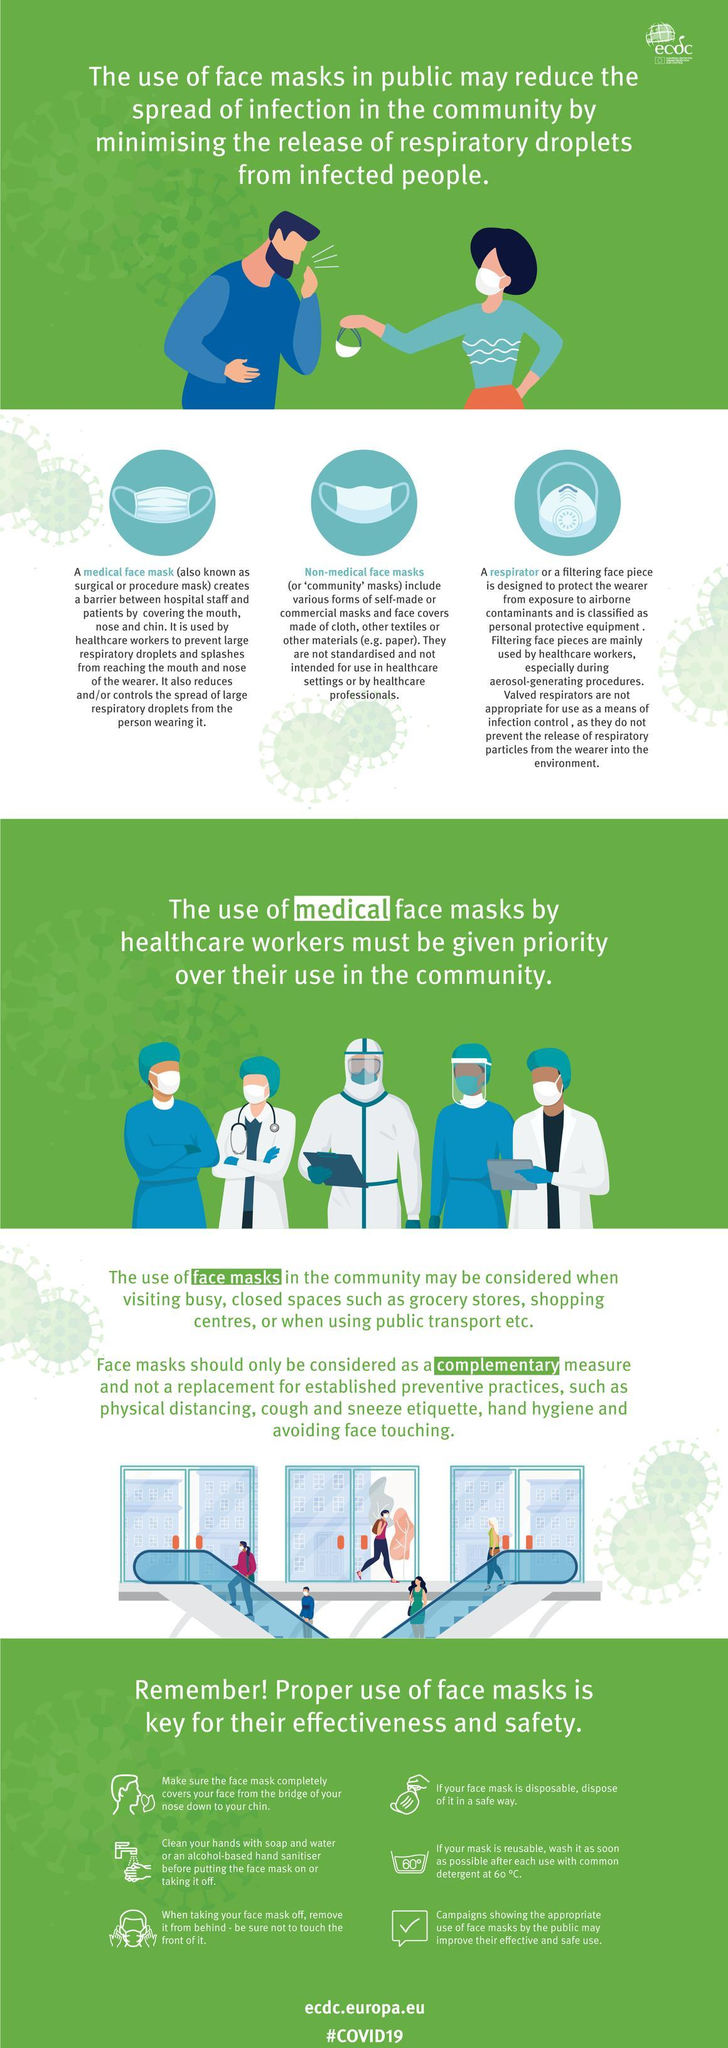Which type of mask is designed to protect the wearer from airborne contaminants?
Answer the question with a short phrase. Respirator What is another name for Non medical face masks? Community masks While taking off your face mask, which part of it should one avoid touching? Front What are the three types of face masks shown here? Medical face mask, non medical face mask, respirator What should you use to wash your reusable face mask? Detergent How many steps of proper use of face masks are shown here? 6 What type of face mask do health workers use? Medical face mask 